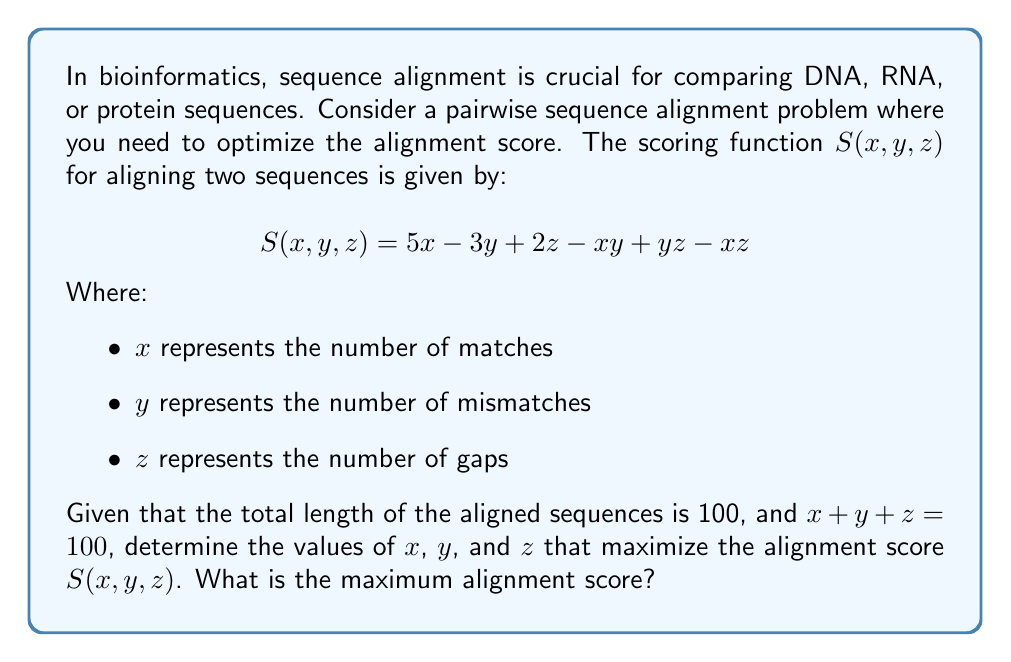Can you answer this question? To solve this optimization problem, we'll use the method of Lagrange multipliers, which is suitable for constrained optimization problems.

1. Define the Lagrangian function:
   $$L(x, y, z, \lambda) = S(x, y, z) - \lambda(x + y + z - 100)$$
   $$L(x, y, z, \lambda) = 5x - 3y + 2z - xy + yz - xz - \lambda(x + y + z - 100)$$

2. Calculate partial derivatives and set them to zero:
   $$\frac{\partial L}{\partial x} = 5 - y - z - \lambda = 0$$
   $$\frac{\partial L}{\partial y} = -3 - x + z - \lambda = 0$$
   $$\frac{\partial L}{\partial z} = 2 + y - x - \lambda = 0$$
   $$\frac{\partial L}{\partial \lambda} = x + y + z - 100 = 0$$

3. From these equations, we can deduce:
   $5 - y - z = -3 - x + z = 2 + y - x$

4. Solving these equations:
   $x - y = 8$
   $x - z = 3$
   $y - z = -5$

5. Substituting into the constraint equation:
   $x + (x - 8) + (x - 3) = 100$
   $3x - 11 = 100$
   $x = 37$

6. Now we can find y and z:
   $y = x - 8 = 29$
   $z = x - 3 = 34$

7. Verify that $x + y + z = 100$:
   $37 + 29 + 34 = 100$

8. Calculate the maximum score:
   $$S(37, 29, 34) = 5(37) - 3(29) + 2(34) - 37(29) + 29(34) - 37(34)$$
   $$= 185 - 87 + 68 - 1073 + 986 - 1258 = -1179$$
Answer: The optimal values are $x = 37$ (matches), $y = 29$ (mismatches), and $z = 34$ (gaps). The maximum alignment score is $-1179$. 